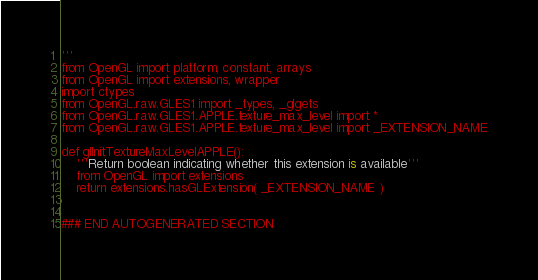Convert code to text. <code><loc_0><loc_0><loc_500><loc_500><_Python_>'''
from OpenGL import platform, constant, arrays
from OpenGL import extensions, wrapper
import ctypes
from OpenGL.raw.GLES1 import _types, _glgets
from OpenGL.raw.GLES1.APPLE.texture_max_level import *
from OpenGL.raw.GLES1.APPLE.texture_max_level import _EXTENSION_NAME

def glInitTextureMaxLevelAPPLE():
    '''Return boolean indicating whether this extension is available'''
    from OpenGL import extensions
    return extensions.hasGLExtension( _EXTENSION_NAME )


### END AUTOGENERATED SECTION</code> 